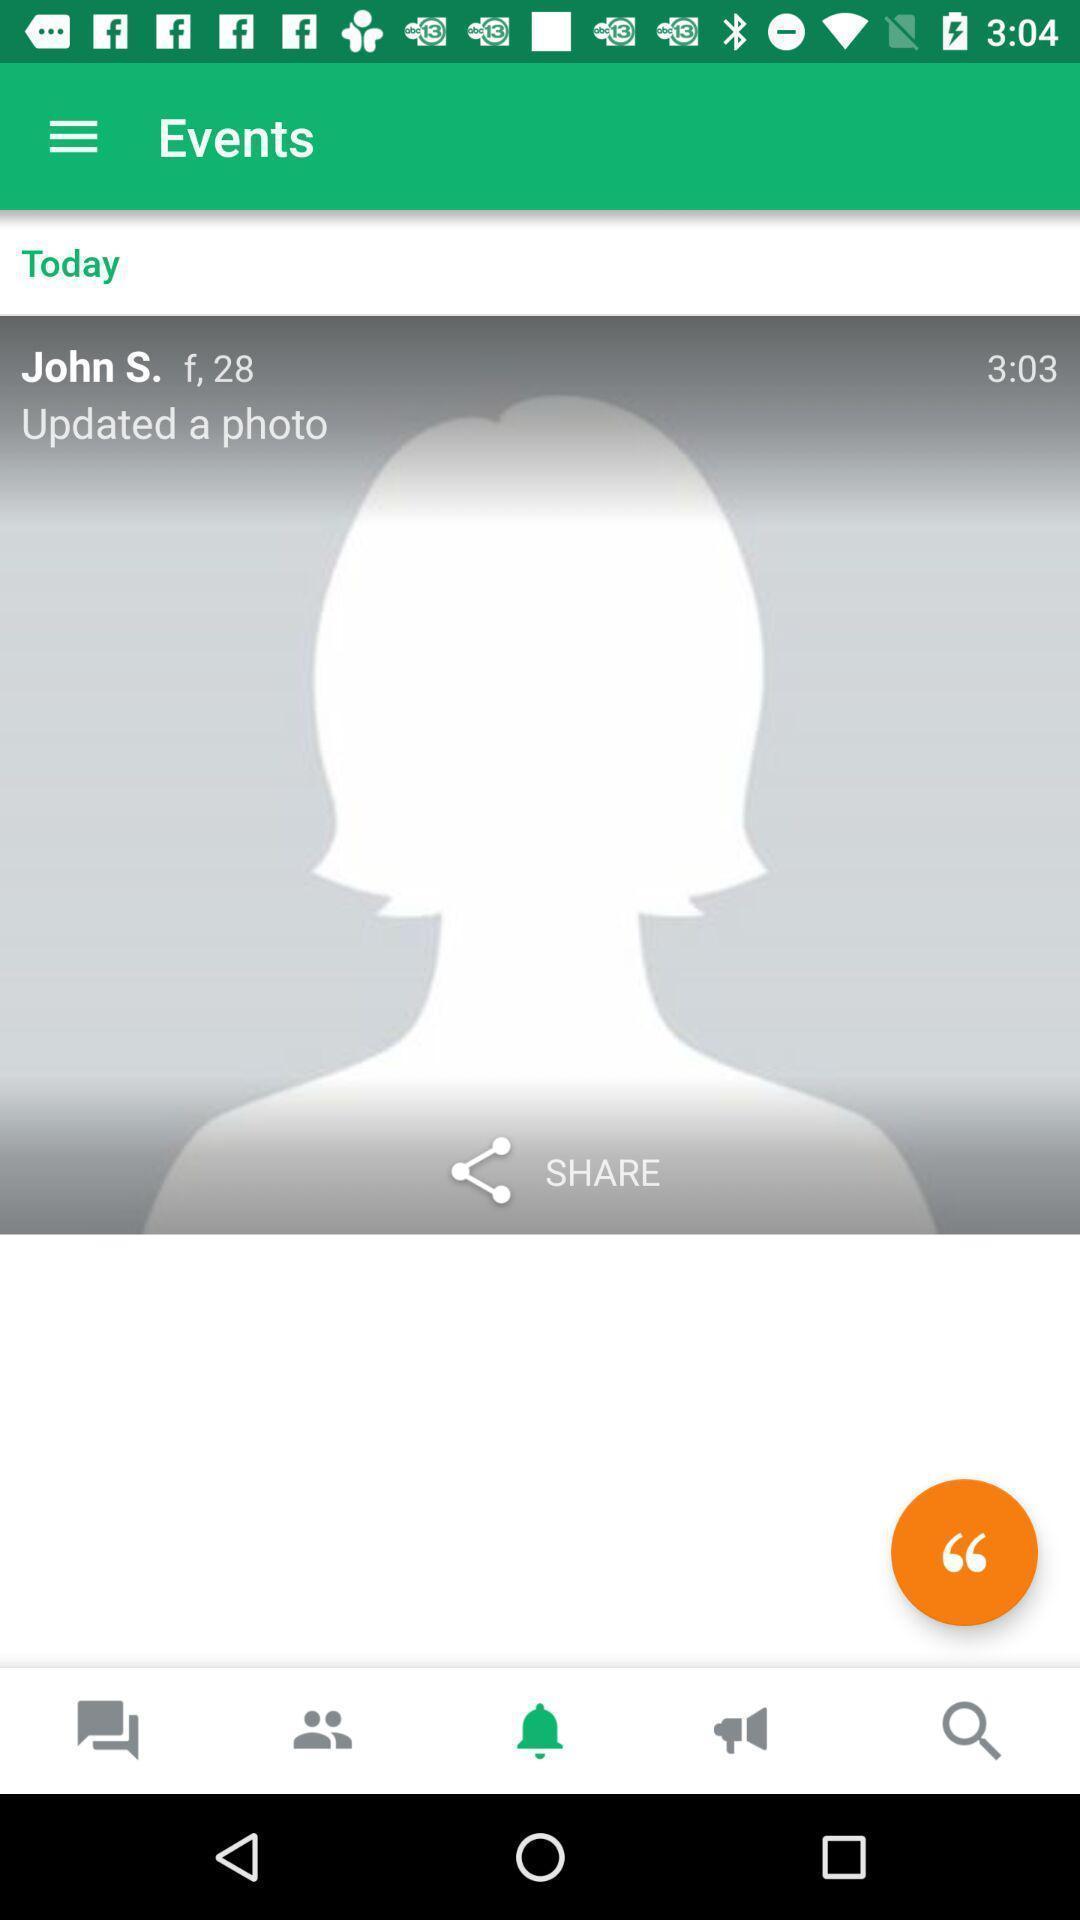What can you discern from this picture? Screen shows events page with profile in chat application. 